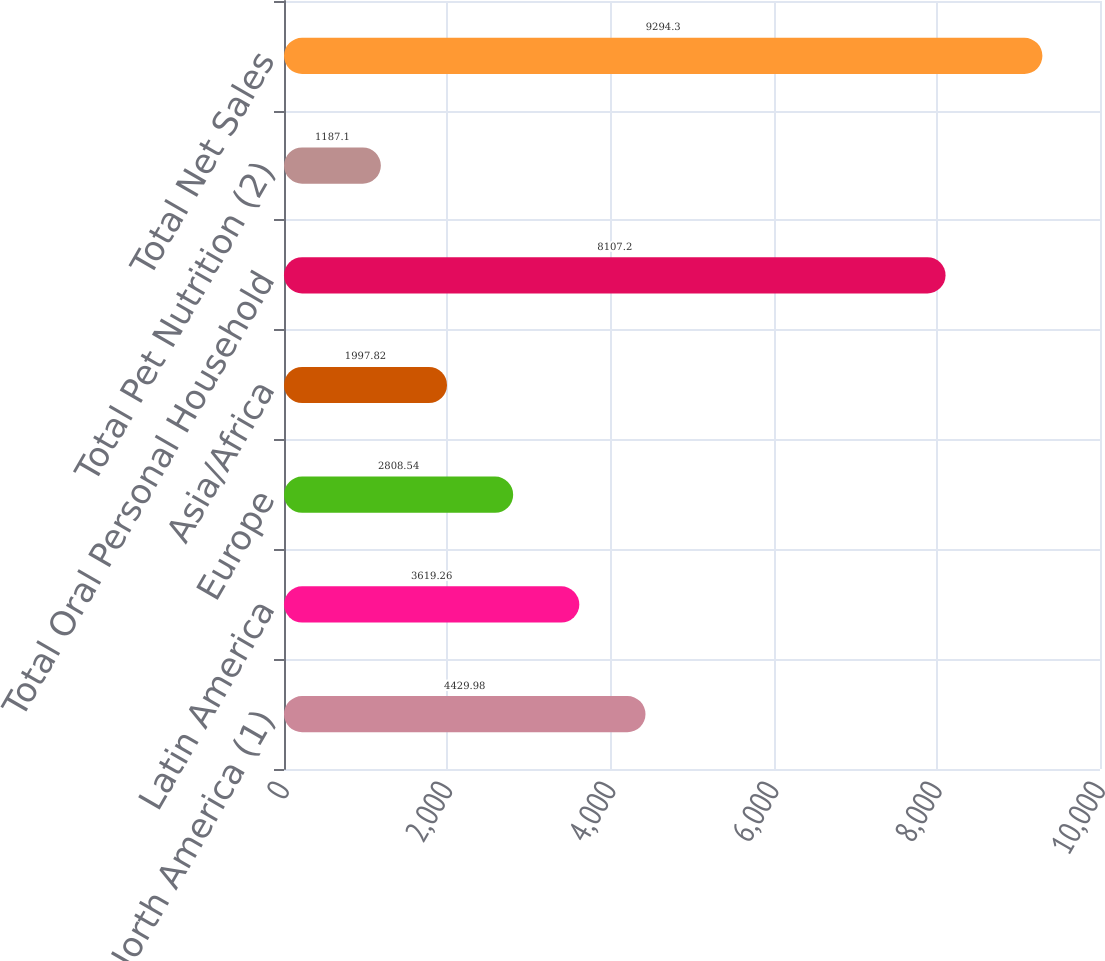Convert chart to OTSL. <chart><loc_0><loc_0><loc_500><loc_500><bar_chart><fcel>North America (1)<fcel>Latin America<fcel>Europe<fcel>Asia/Africa<fcel>Total Oral Personal Household<fcel>Total Pet Nutrition (2)<fcel>Total Net Sales<nl><fcel>4429.98<fcel>3619.26<fcel>2808.54<fcel>1997.82<fcel>8107.2<fcel>1187.1<fcel>9294.3<nl></chart> 